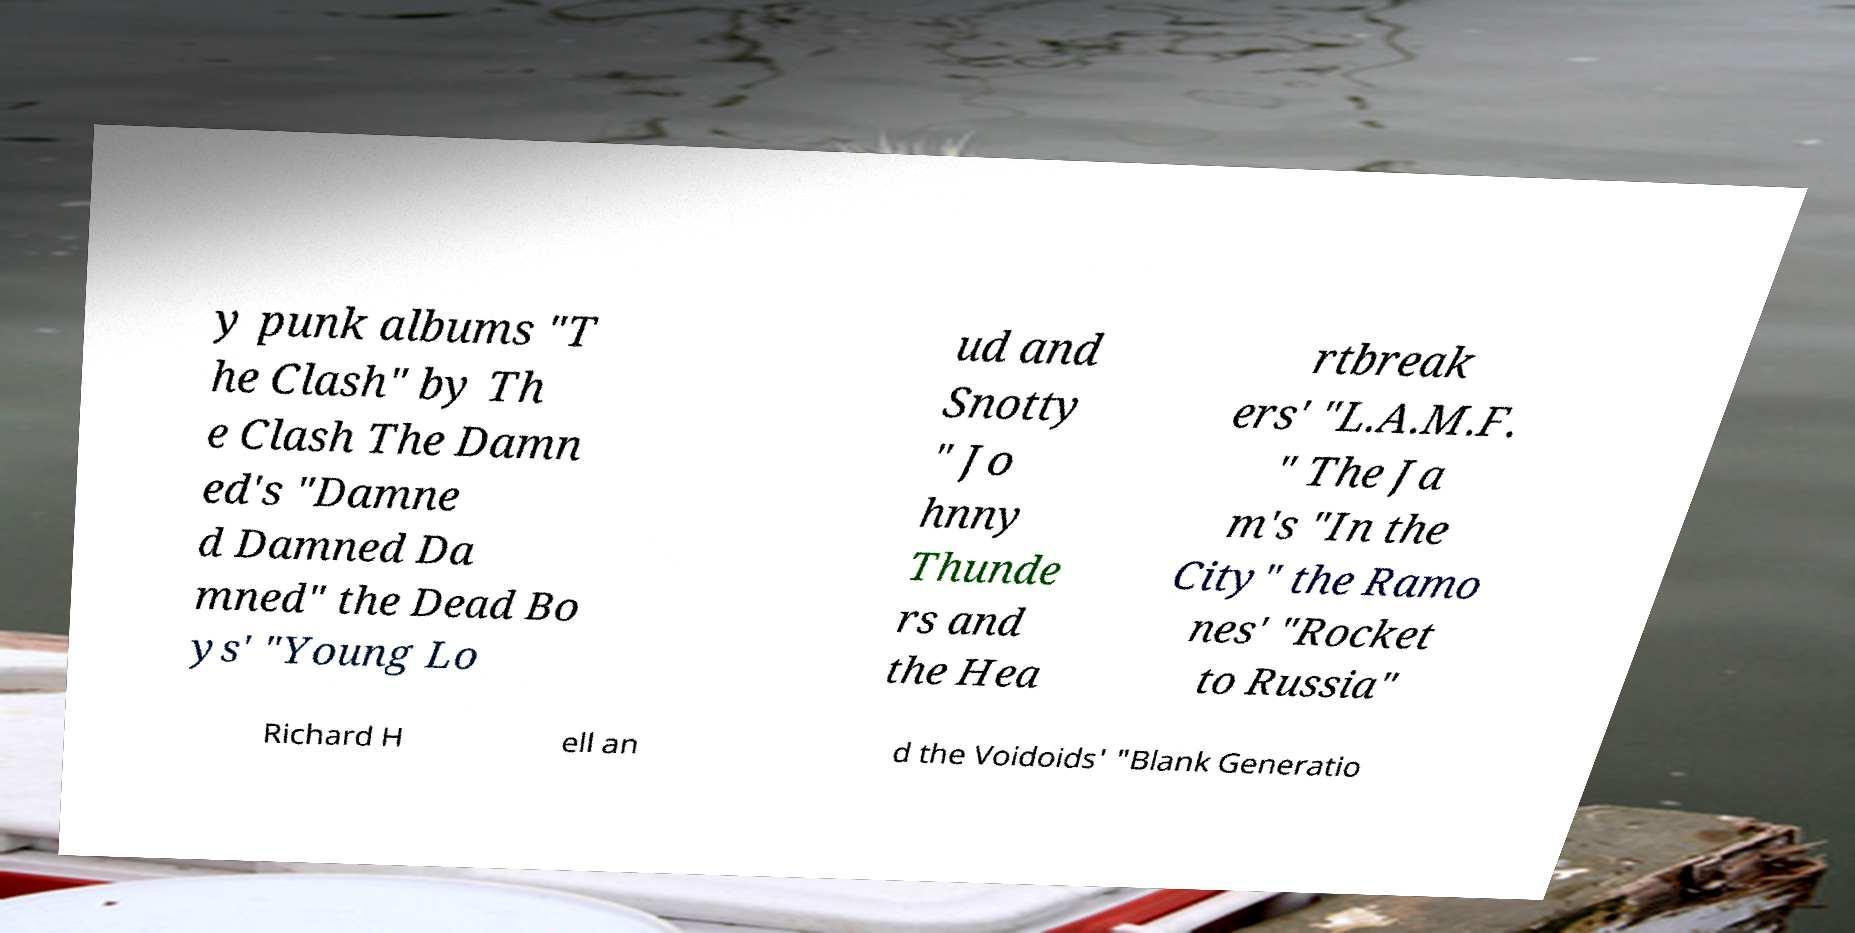Could you assist in decoding the text presented in this image and type it out clearly? y punk albums "T he Clash" by Th e Clash The Damn ed's "Damne d Damned Da mned" the Dead Bo ys' "Young Lo ud and Snotty " Jo hnny Thunde rs and the Hea rtbreak ers' "L.A.M.F. " The Ja m's "In the City" the Ramo nes' "Rocket to Russia" Richard H ell an d the Voidoids' "Blank Generatio 